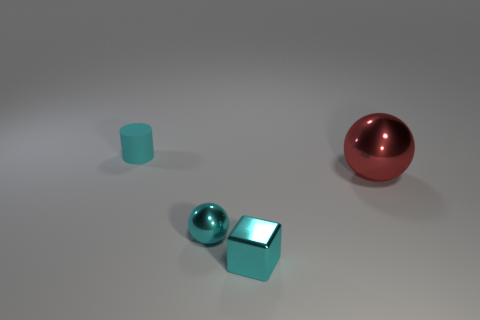Add 3 balls. How many objects exist? 7 Subtract all blocks. How many objects are left? 3 Subtract all cyan shiny cylinders. Subtract all cyan objects. How many objects are left? 1 Add 1 large things. How many large things are left? 2 Add 1 cubes. How many cubes exist? 2 Subtract 0 gray blocks. How many objects are left? 4 Subtract all brown spheres. Subtract all brown cylinders. How many spheres are left? 2 